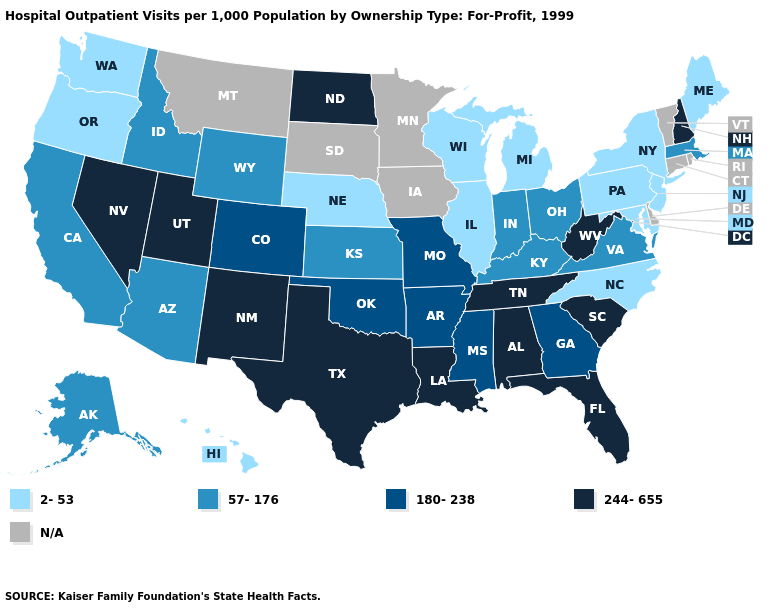What is the highest value in states that border Florida?
Answer briefly. 244-655. What is the value of Washington?
Concise answer only. 2-53. What is the value of South Dakota?
Keep it brief. N/A. What is the highest value in states that border Georgia?
Short answer required. 244-655. Among the states that border Washington , does Idaho have the highest value?
Write a very short answer. Yes. What is the value of New Hampshire?
Answer briefly. 244-655. Name the states that have a value in the range 57-176?
Keep it brief. Alaska, Arizona, California, Idaho, Indiana, Kansas, Kentucky, Massachusetts, Ohio, Virginia, Wyoming. What is the value of Georgia?
Answer briefly. 180-238. Among the states that border Maryland , which have the highest value?
Answer briefly. West Virginia. Among the states that border Louisiana , which have the highest value?
Give a very brief answer. Texas. Among the states that border Ohio , which have the highest value?
Quick response, please. West Virginia. What is the lowest value in the South?
Be succinct. 2-53. Does Florida have the highest value in the South?
Concise answer only. Yes. Among the states that border Florida , which have the lowest value?
Quick response, please. Georgia. 